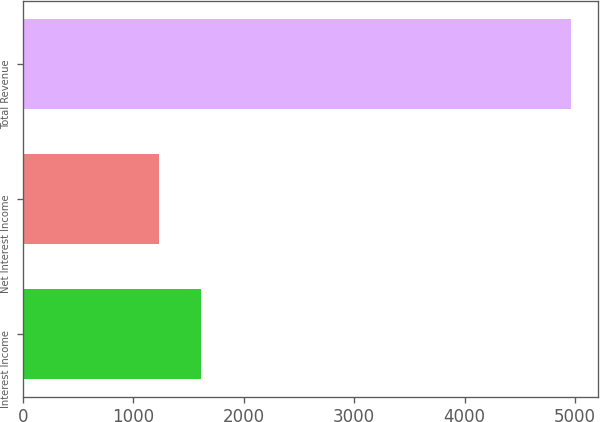Convert chart to OTSL. <chart><loc_0><loc_0><loc_500><loc_500><bar_chart><fcel>Interest Income<fcel>Net Interest Income<fcel>Total Revenue<nl><fcel>1607.59<fcel>1234.9<fcel>4961.8<nl></chart> 